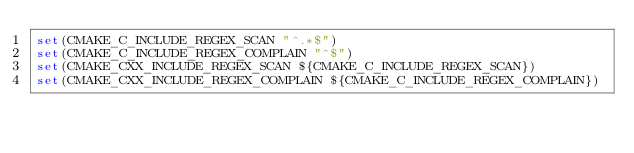Convert code to text. <code><loc_0><loc_0><loc_500><loc_500><_CMake_>set(CMAKE_C_INCLUDE_REGEX_SCAN "^.*$")
set(CMAKE_C_INCLUDE_REGEX_COMPLAIN "^$")
set(CMAKE_CXX_INCLUDE_REGEX_SCAN ${CMAKE_C_INCLUDE_REGEX_SCAN})
set(CMAKE_CXX_INCLUDE_REGEX_COMPLAIN ${CMAKE_C_INCLUDE_REGEX_COMPLAIN})
</code> 